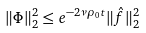Convert formula to latex. <formula><loc_0><loc_0><loc_500><loc_500>\| \Phi \| _ { 2 } ^ { 2 } \leq e ^ { - 2 \nu \rho _ { 0 } t } \| \hat { f } \| _ { 2 } ^ { 2 }</formula> 